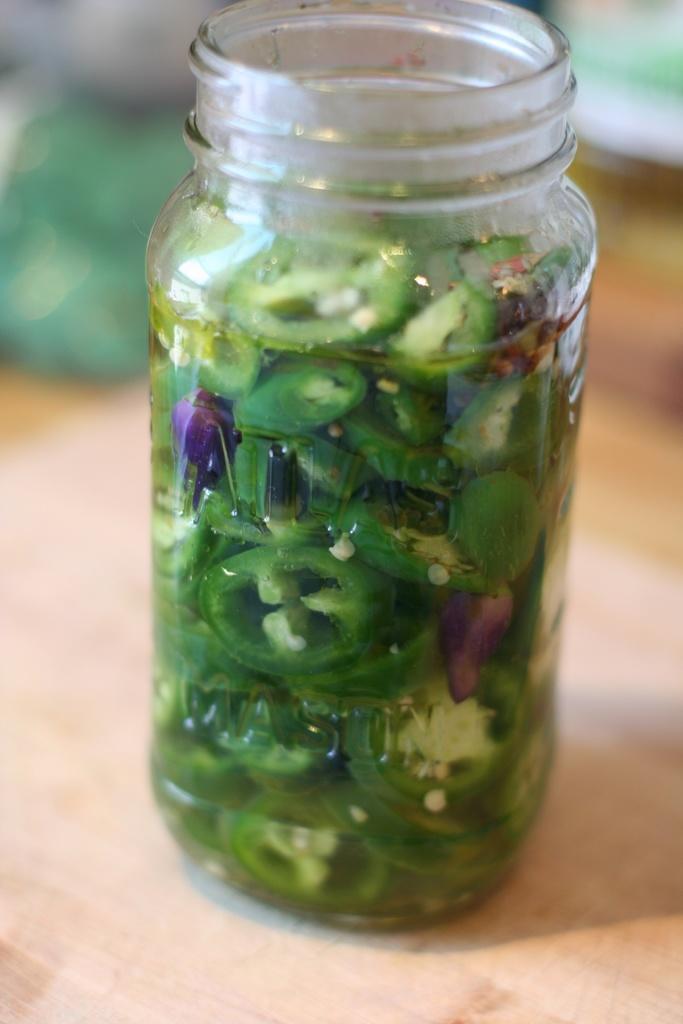Please provide a concise description of this image. In this image we can see the capsicum slices in a glass jar and it is placed on the wooden surface. 